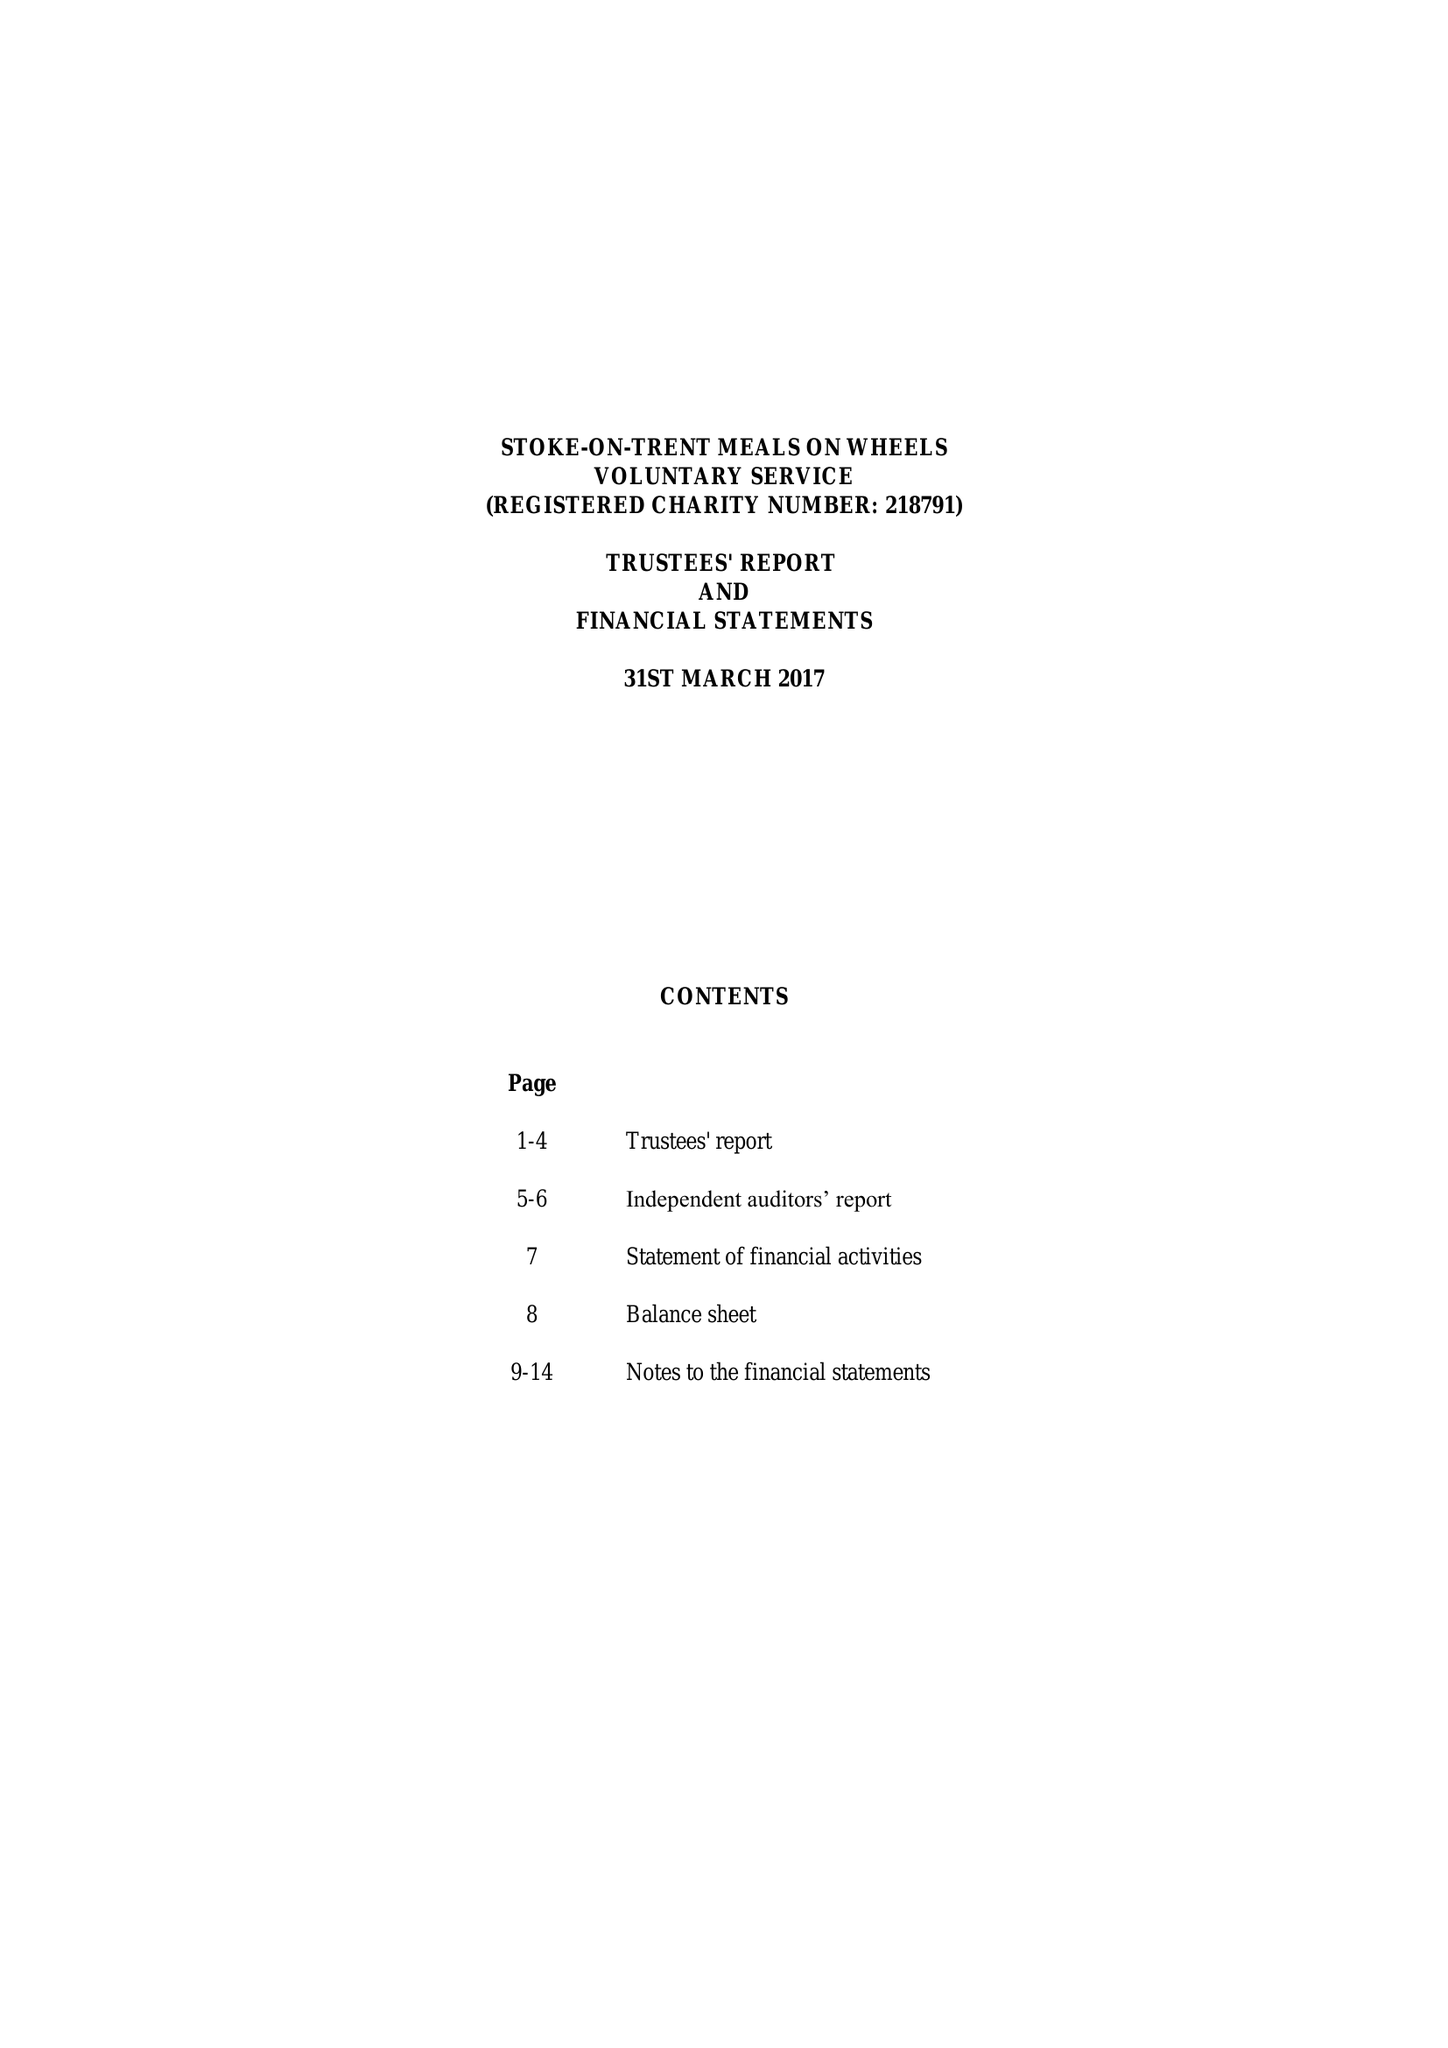What is the value for the report_date?
Answer the question using a single word or phrase. 2017-03-31 